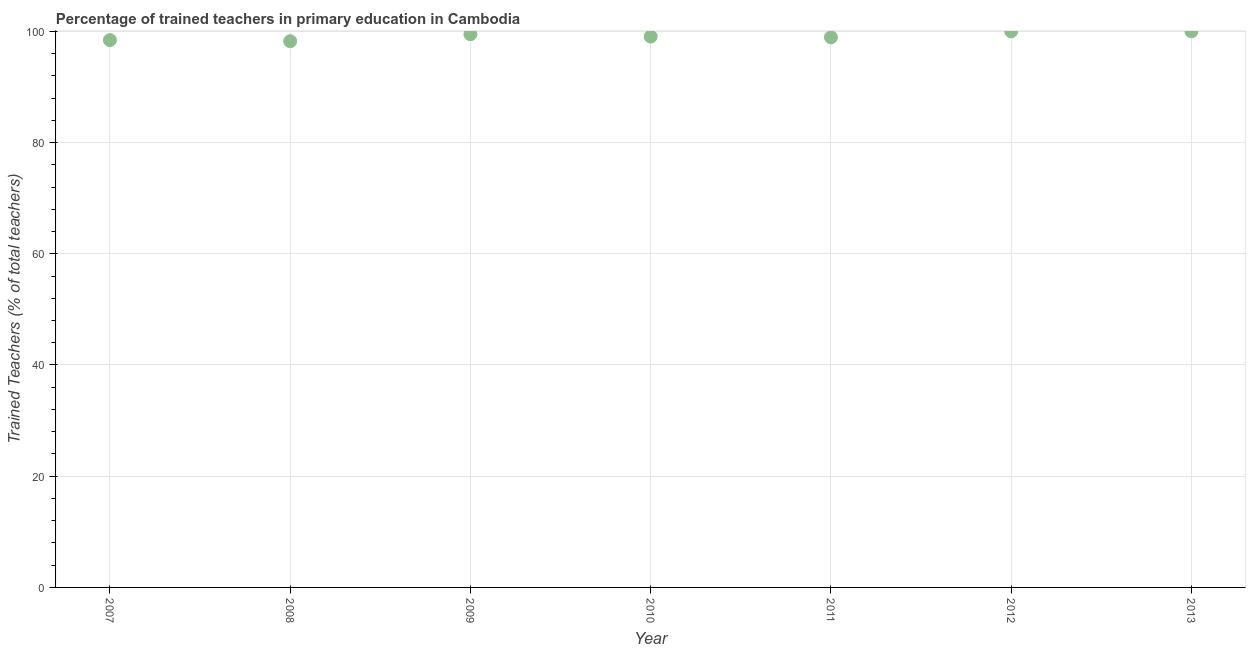What is the percentage of trained teachers in 2008?
Keep it short and to the point. 98.22. Across all years, what is the maximum percentage of trained teachers?
Ensure brevity in your answer.  100. Across all years, what is the minimum percentage of trained teachers?
Ensure brevity in your answer.  98.22. What is the sum of the percentage of trained teachers?
Provide a succinct answer. 694.09. What is the difference between the percentage of trained teachers in 2008 and 2011?
Provide a short and direct response. -0.71. What is the average percentage of trained teachers per year?
Keep it short and to the point. 99.16. What is the median percentage of trained teachers?
Make the answer very short. 99.06. What is the ratio of the percentage of trained teachers in 2007 to that in 2012?
Give a very brief answer. 0.98. Is the difference between the percentage of trained teachers in 2011 and 2012 greater than the difference between any two years?
Provide a short and direct response. No. What is the difference between the highest and the lowest percentage of trained teachers?
Your answer should be very brief. 1.78. In how many years, is the percentage of trained teachers greater than the average percentage of trained teachers taken over all years?
Your answer should be very brief. 3. How many dotlines are there?
Offer a terse response. 1. How many years are there in the graph?
Your response must be concise. 7. What is the difference between two consecutive major ticks on the Y-axis?
Your answer should be very brief. 20. Are the values on the major ticks of Y-axis written in scientific E-notation?
Ensure brevity in your answer.  No. Does the graph contain any zero values?
Offer a terse response. No. What is the title of the graph?
Your answer should be compact. Percentage of trained teachers in primary education in Cambodia. What is the label or title of the X-axis?
Offer a terse response. Year. What is the label or title of the Y-axis?
Keep it short and to the point. Trained Teachers (% of total teachers). What is the Trained Teachers (% of total teachers) in 2007?
Provide a short and direct response. 98.41. What is the Trained Teachers (% of total teachers) in 2008?
Keep it short and to the point. 98.22. What is the Trained Teachers (% of total teachers) in 2009?
Make the answer very short. 99.48. What is the Trained Teachers (% of total teachers) in 2010?
Offer a very short reply. 99.06. What is the Trained Teachers (% of total teachers) in 2011?
Offer a terse response. 98.93. What is the Trained Teachers (% of total teachers) in 2012?
Make the answer very short. 100. What is the difference between the Trained Teachers (% of total teachers) in 2007 and 2008?
Provide a succinct answer. 0.2. What is the difference between the Trained Teachers (% of total teachers) in 2007 and 2009?
Provide a short and direct response. -1.07. What is the difference between the Trained Teachers (% of total teachers) in 2007 and 2010?
Ensure brevity in your answer.  -0.64. What is the difference between the Trained Teachers (% of total teachers) in 2007 and 2011?
Provide a succinct answer. -0.51. What is the difference between the Trained Teachers (% of total teachers) in 2007 and 2012?
Provide a short and direct response. -1.59. What is the difference between the Trained Teachers (% of total teachers) in 2007 and 2013?
Provide a short and direct response. -1.59. What is the difference between the Trained Teachers (% of total teachers) in 2008 and 2009?
Your answer should be compact. -1.26. What is the difference between the Trained Teachers (% of total teachers) in 2008 and 2010?
Your answer should be compact. -0.84. What is the difference between the Trained Teachers (% of total teachers) in 2008 and 2011?
Make the answer very short. -0.71. What is the difference between the Trained Teachers (% of total teachers) in 2008 and 2012?
Make the answer very short. -1.78. What is the difference between the Trained Teachers (% of total teachers) in 2008 and 2013?
Provide a short and direct response. -1.78. What is the difference between the Trained Teachers (% of total teachers) in 2009 and 2010?
Ensure brevity in your answer.  0.42. What is the difference between the Trained Teachers (% of total teachers) in 2009 and 2011?
Your answer should be very brief. 0.55. What is the difference between the Trained Teachers (% of total teachers) in 2009 and 2012?
Give a very brief answer. -0.52. What is the difference between the Trained Teachers (% of total teachers) in 2009 and 2013?
Provide a succinct answer. -0.52. What is the difference between the Trained Teachers (% of total teachers) in 2010 and 2011?
Ensure brevity in your answer.  0.13. What is the difference between the Trained Teachers (% of total teachers) in 2010 and 2012?
Provide a short and direct response. -0.94. What is the difference between the Trained Teachers (% of total teachers) in 2010 and 2013?
Make the answer very short. -0.94. What is the difference between the Trained Teachers (% of total teachers) in 2011 and 2012?
Give a very brief answer. -1.07. What is the difference between the Trained Teachers (% of total teachers) in 2011 and 2013?
Your answer should be very brief. -1.07. What is the difference between the Trained Teachers (% of total teachers) in 2012 and 2013?
Ensure brevity in your answer.  0. What is the ratio of the Trained Teachers (% of total teachers) in 2007 to that in 2009?
Keep it short and to the point. 0.99. What is the ratio of the Trained Teachers (% of total teachers) in 2007 to that in 2010?
Keep it short and to the point. 0.99. What is the ratio of the Trained Teachers (% of total teachers) in 2007 to that in 2011?
Give a very brief answer. 0.99. What is the ratio of the Trained Teachers (% of total teachers) in 2009 to that in 2013?
Provide a succinct answer. 0.99. What is the ratio of the Trained Teachers (% of total teachers) in 2010 to that in 2011?
Your answer should be compact. 1. What is the ratio of the Trained Teachers (% of total teachers) in 2010 to that in 2012?
Keep it short and to the point. 0.99. What is the ratio of the Trained Teachers (% of total teachers) in 2011 to that in 2012?
Your answer should be compact. 0.99. What is the ratio of the Trained Teachers (% of total teachers) in 2011 to that in 2013?
Ensure brevity in your answer.  0.99. What is the ratio of the Trained Teachers (% of total teachers) in 2012 to that in 2013?
Offer a very short reply. 1. 